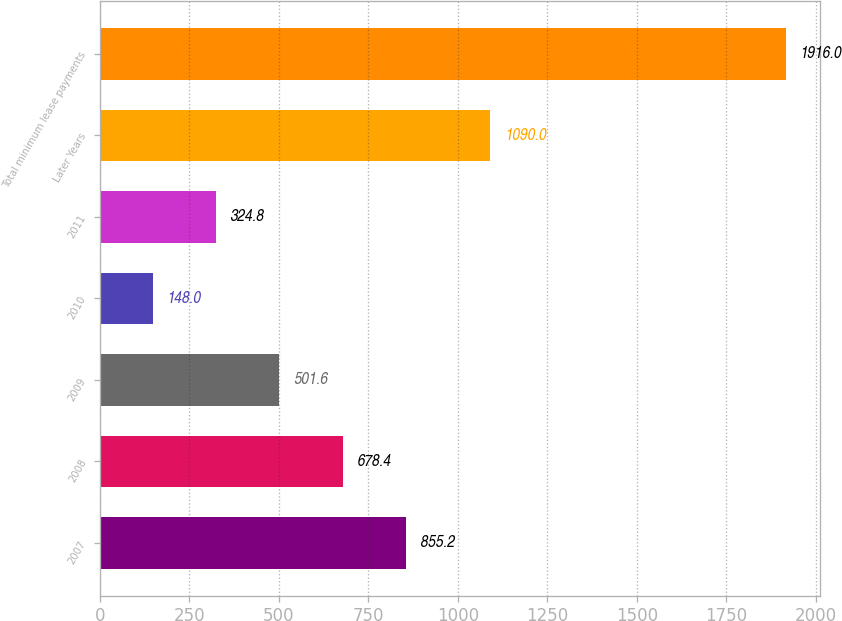<chart> <loc_0><loc_0><loc_500><loc_500><bar_chart><fcel>2007<fcel>2008<fcel>2009<fcel>2010<fcel>2011<fcel>Later Years<fcel>Total minimum lease payments<nl><fcel>855.2<fcel>678.4<fcel>501.6<fcel>148<fcel>324.8<fcel>1090<fcel>1916<nl></chart> 